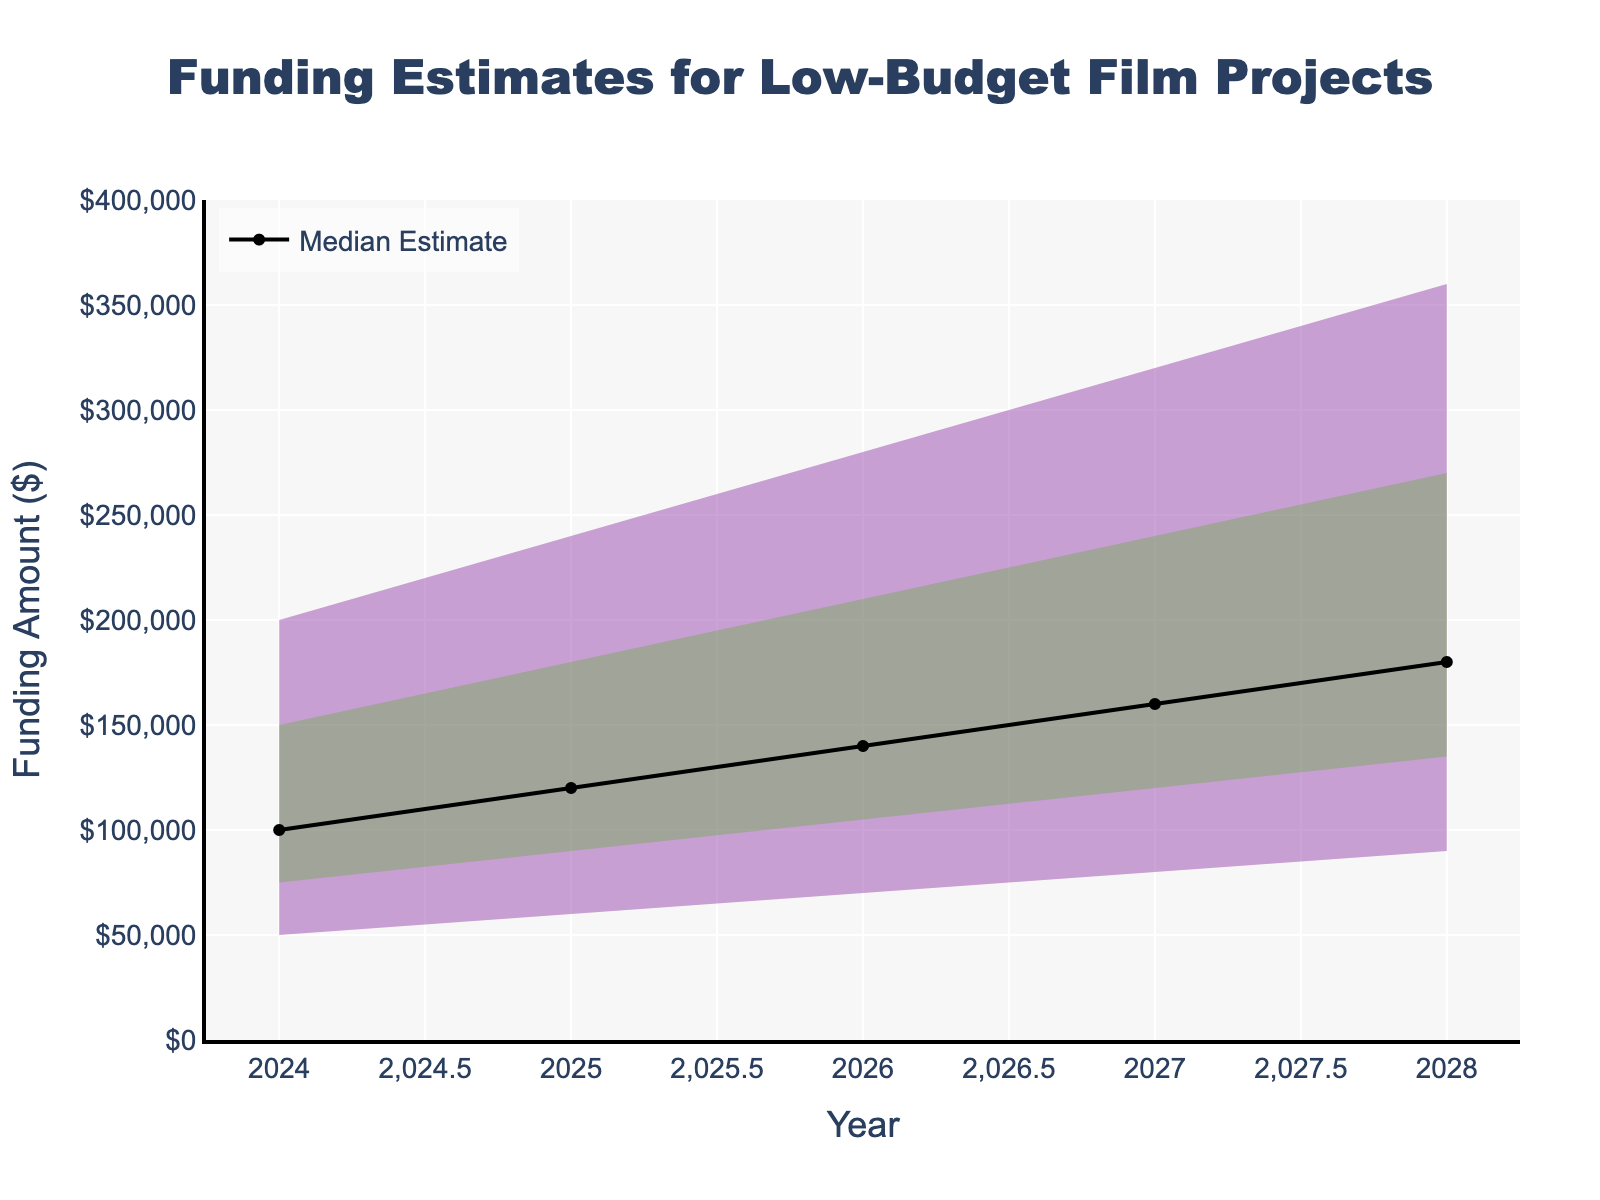What is the title of the chart? The title of the chart is displayed at the top and reads 'Funding Estimates for Low-Budget Film Projects.'
Answer: Funding Estimates for Low-Budget Film Projects What is the color of the area representing the highest estimate? The color associated with the highest estimate is blue, as shown by the shaded area in the fan chart.
Answer: Blue In what year is the median funding estimate $140,000? The median funding estimate of $140,000 is shown on the y-axis and corresponds to 2026 on the x-axis.
Answer: 2026 What is the range for the funding estimates in 2027? The range for 2027 is from $80,000 to $320,000, as indicated by the lowest and highest estimates on the y-axis for that year.
Answer: $80,000 to $320,000 By how much does the high estimate increase from 2024 to 2028? The high estimate in 2024 is $200,000 and in 2028 it is $360,000. The increase is $360,000 - $200,000 = $160,000.
Answer: $160,000 Which year shows the smallest funding estimate according to the chart? The smallest funding estimate is shown in 2024, with a low estimate of $50,000.
Answer: 2024 By how much does the low-mid estimate increase from 2025 to 2026? In 2025, the low-mid estimate is $90,000, and in 2026, it is $105,000. The increase is $105,000 - $90,000 = $15,000.
Answer: $15,000 Which estimate band is colored green in the fan chart? The green color in the fan chart represents the mid-high estimate band.
Answer: Mid-High Estimate What is the shape of the line representing the median estimate over the years? The median estimate is represented by a black line that steadily increases over the years.
Answer: Steadily increasing How do the estimates illustrate potential financial scenarios over time? The estimates widen over time, indicating increasing uncertainty in the funding projections. This is depicted by the fan sections growing larger from 2024 to 2028.
Answer: Increasing uncertainty over time 